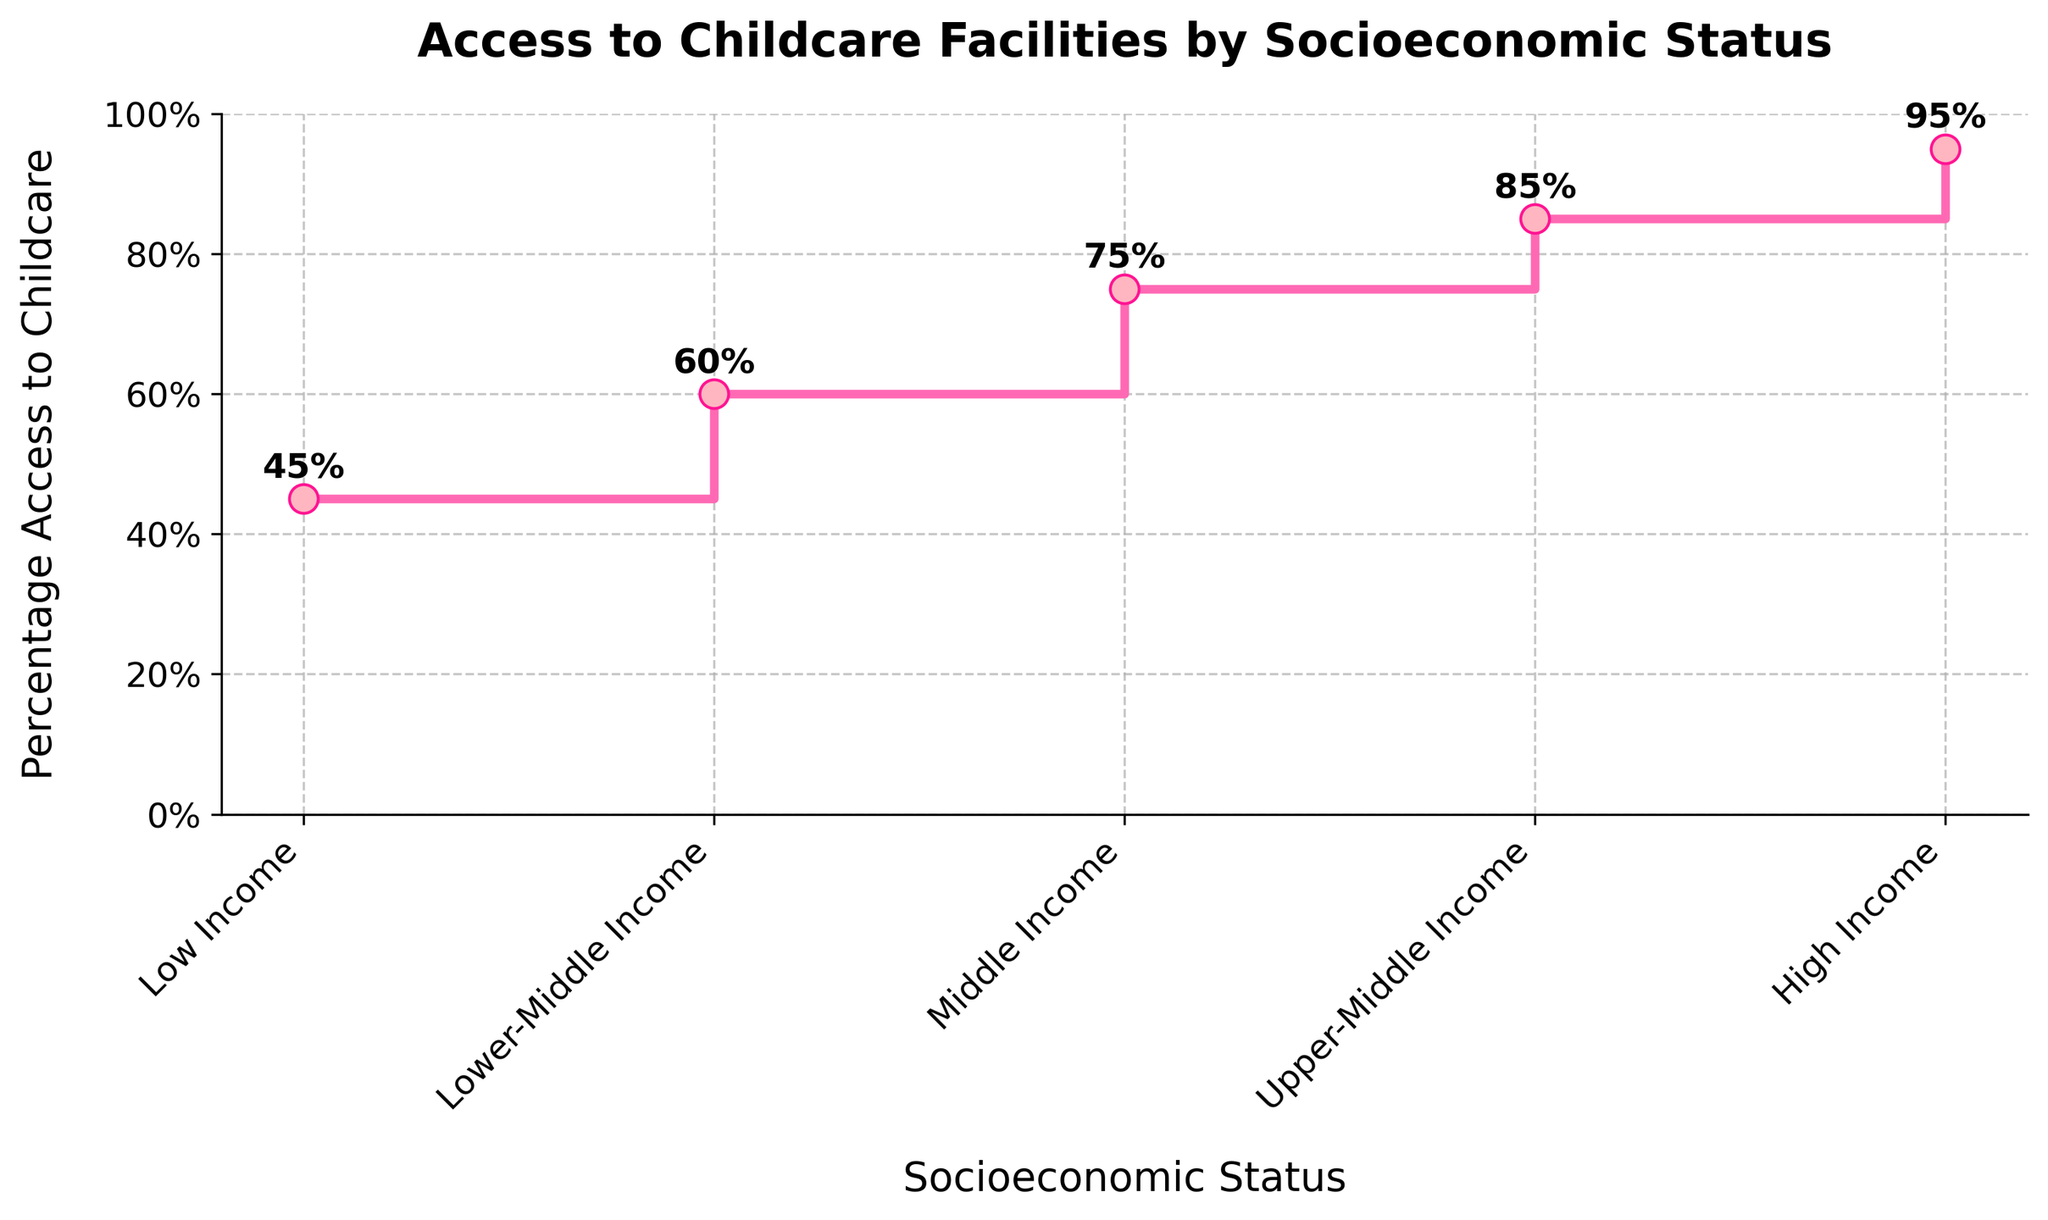What is the title of the plot? The title is shown at the top of the plot. It reads "Access to Childcare Facilities by Socioeconomic Status".
Answer: Access to Childcare Facilities by Socioeconomic Status What socioeconomic status group has the highest access to childcare facilities? The group with the highest percentage of access can be identified at the topmost data point in the plot. The High Income group has 95% access.
Answer: High Income Which group has the lowest access to childcare facilities? The group with the lowest percentage of access is the bottommost data point. The Low Income group has 45% access.
Answer: Low Income What is the percentage access to childcare facilities for the Middle Income group? Find the Middle Income group on the x-axis and refer to the corresponding y-axis value. It is shown as 75%.
Answer: 75% By how much does the percentage access to childcare increase from the Low Income group to the Upper-Middle Income group? The percentage access for Low Income is 45%, and for Upper-Middle Income, it is 85%. Subtract 45 from 85 to get the increase.
Answer: 85% - 45% = 40% What is the difference in percentage access to childcare between the Upper-Middle Income group and the Lower-Middle Income group? The value for Upper-Middle Income is 85%, and for Lower-Middle Income, it is 60%. Subtract 60 from 85.
Answer: 85% - 60% = 25% How many data points are there in the plot? Count the number of groups listed on the x-axis. There are five groups shown: Low Income, Lower-Middle Income, Middle Income, Upper-Middle Income, and High Income.
Answer: 5 Do the labels on the y-axis increase by the same amount? Observe the y-axis labels: 0, 20, 40, 60, 80, 100. They increase by intervals of 20%.
Answer: Yes What can you infer about the relationship between socioeconomic status and access to childcare facilities? The plot shows that as socioeconomic status increases from Low Income to High Income, the percentage access to childcare facilities also increases steadily. This is evident from the stepwise rise in the plot.
Answer: Higher socioeconomic status groups have greater access to childcare facilities Which two groups have the smallest difference in their percentage access to childcare facilities? The smallest difference can be identified by comparing the percentage access values between consecutive groups. The smallest difference is between Upper-Middle Income (85%) and Middle Income (75%), which is 10%.
Answer: Upper-Middle Income and Middle Income 